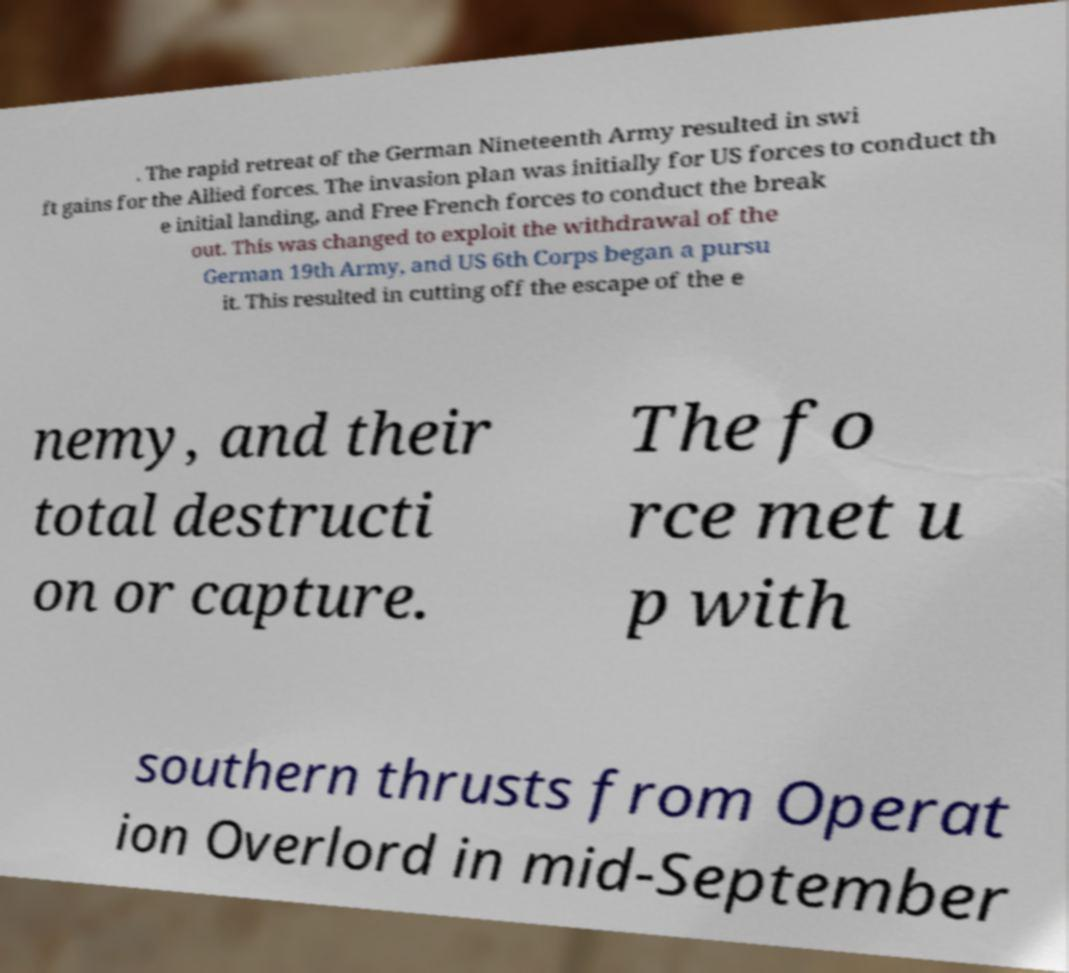Please identify and transcribe the text found in this image. . The rapid retreat of the German Nineteenth Army resulted in swi ft gains for the Allied forces. The invasion plan was initially for US forces to conduct th e initial landing, and Free French forces to conduct the break out. This was changed to exploit the withdrawal of the German 19th Army, and US 6th Corps began a pursu it. This resulted in cutting off the escape of the e nemy, and their total destructi on or capture. The fo rce met u p with southern thrusts from Operat ion Overlord in mid-September 